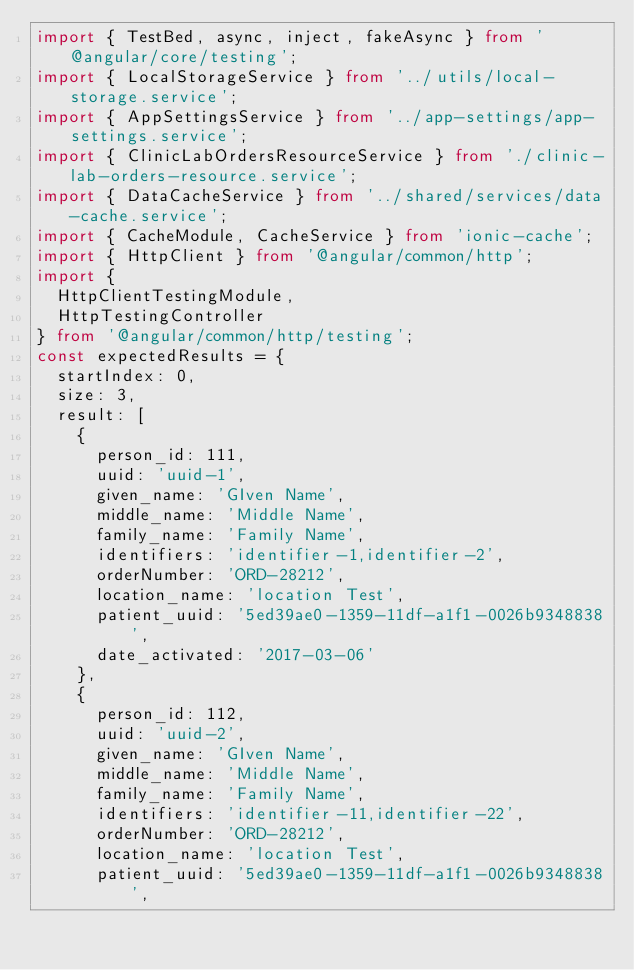<code> <loc_0><loc_0><loc_500><loc_500><_TypeScript_>import { TestBed, async, inject, fakeAsync } from '@angular/core/testing';
import { LocalStorageService } from '../utils/local-storage.service';
import { AppSettingsService } from '../app-settings/app-settings.service';
import { ClinicLabOrdersResourceService } from './clinic-lab-orders-resource.service';
import { DataCacheService } from '../shared/services/data-cache.service';
import { CacheModule, CacheService } from 'ionic-cache';
import { HttpClient } from '@angular/common/http';
import {
  HttpClientTestingModule,
  HttpTestingController
} from '@angular/common/http/testing';
const expectedResults = {
  startIndex: 0,
  size: 3,
  result: [
    {
      person_id: 111,
      uuid: 'uuid-1',
      given_name: 'GIven Name',
      middle_name: 'Middle Name',
      family_name: 'Family Name',
      identifiers: 'identifier-1,identifier-2',
      orderNumber: 'ORD-28212',
      location_name: 'location Test',
      patient_uuid: '5ed39ae0-1359-11df-a1f1-0026b9348838',
      date_activated: '2017-03-06'
    },
    {
      person_id: 112,
      uuid: 'uuid-2',
      given_name: 'GIven Name',
      middle_name: 'Middle Name',
      family_name: 'Family Name',
      identifiers: 'identifier-11,identifier-22',
      orderNumber: 'ORD-28212',
      location_name: 'location Test',
      patient_uuid: '5ed39ae0-1359-11df-a1f1-0026b9348838',</code> 